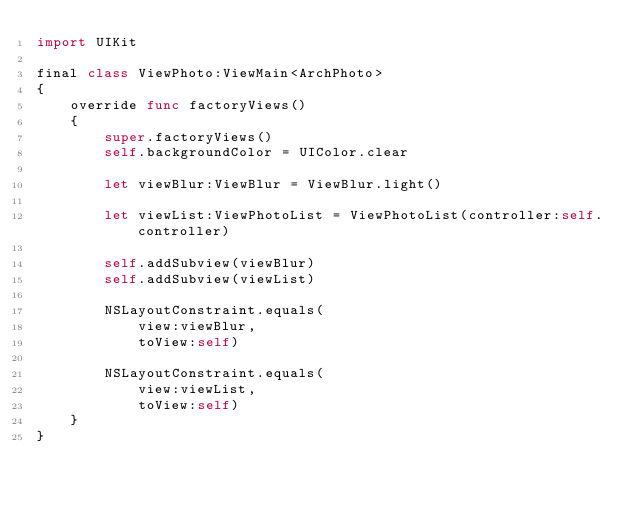<code> <loc_0><loc_0><loc_500><loc_500><_Swift_>import UIKit

final class ViewPhoto:ViewMain<ArchPhoto>
{
    override func factoryViews()
    {
        super.factoryViews()
        self.backgroundColor = UIColor.clear
        
        let viewBlur:ViewBlur = ViewBlur.light()
        
        let viewList:ViewPhotoList = ViewPhotoList(controller:self.controller)
        
        self.addSubview(viewBlur)
        self.addSubview(viewList)
        
        NSLayoutConstraint.equals(
            view:viewBlur,
            toView:self)
        
        NSLayoutConstraint.equals(
            view:viewList,
            toView:self)
    }
}
</code> 